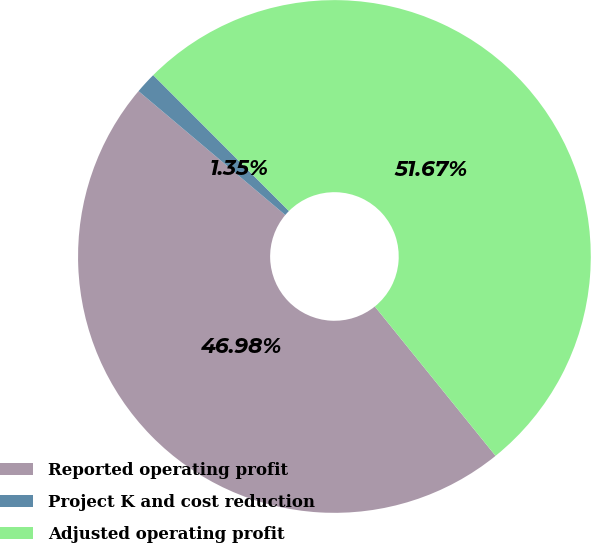Convert chart to OTSL. <chart><loc_0><loc_0><loc_500><loc_500><pie_chart><fcel>Reported operating profit<fcel>Project K and cost reduction<fcel>Adjusted operating profit<nl><fcel>46.98%<fcel>1.35%<fcel>51.68%<nl></chart> 